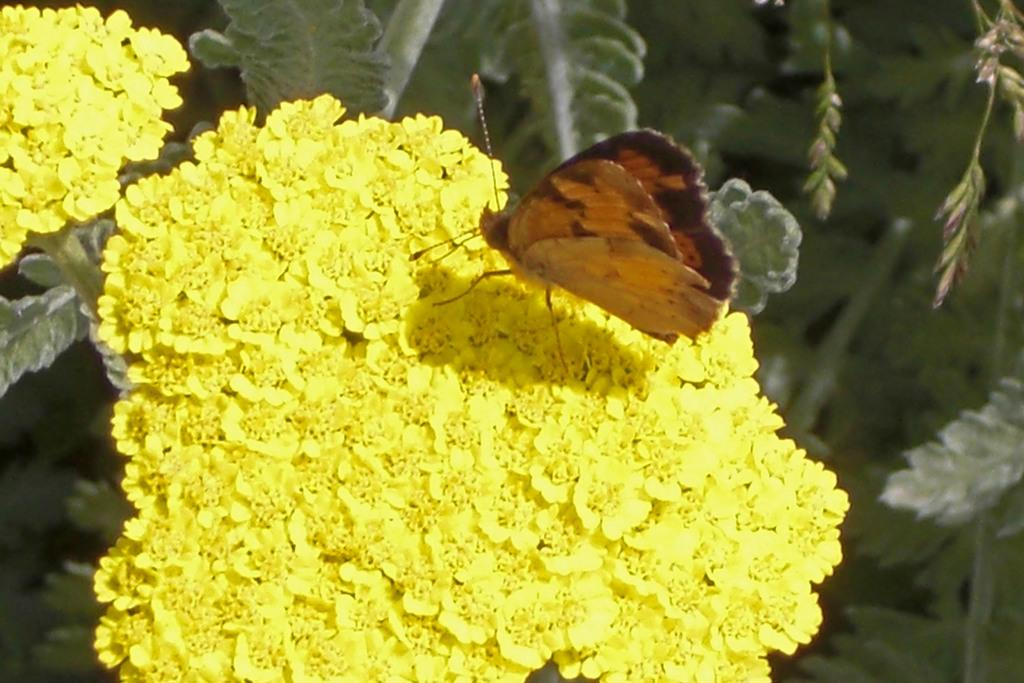What is the main subject of the image? There is a butterfly in the image. Can you describe the color of the butterfly? The butterfly is brown in color. Where is the butterfly located in the image? The butterfly is on a flower. What color is the flower? The flower is yellow. What can be seen in the background of the image? The background of the image includes green leaves. What type of zipper is visible on the butterfly's wing in the image? There is no zipper present on the butterfly's wing in the image. 